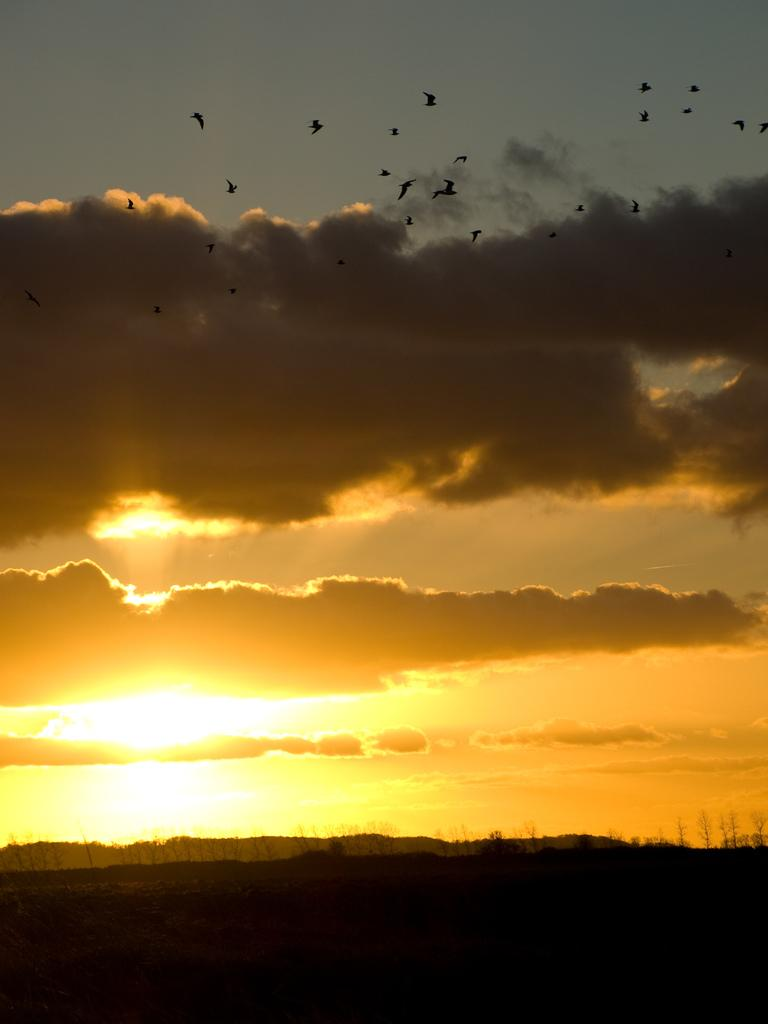What type of vegetation is present in the image? There are trees in the image. What part of the natural environment is visible in the image? The sky is visible in the image. What animals can be seen in the background of the image? Birds are flying in the background of the image. What type of crow is visible in the yard in the image? There is no crow or yard present in the image. How long is the journey of the birds flying in the image? The provided facts do not give information about the distance or duration of the birds' flight, so it cannot be determined from the image. 